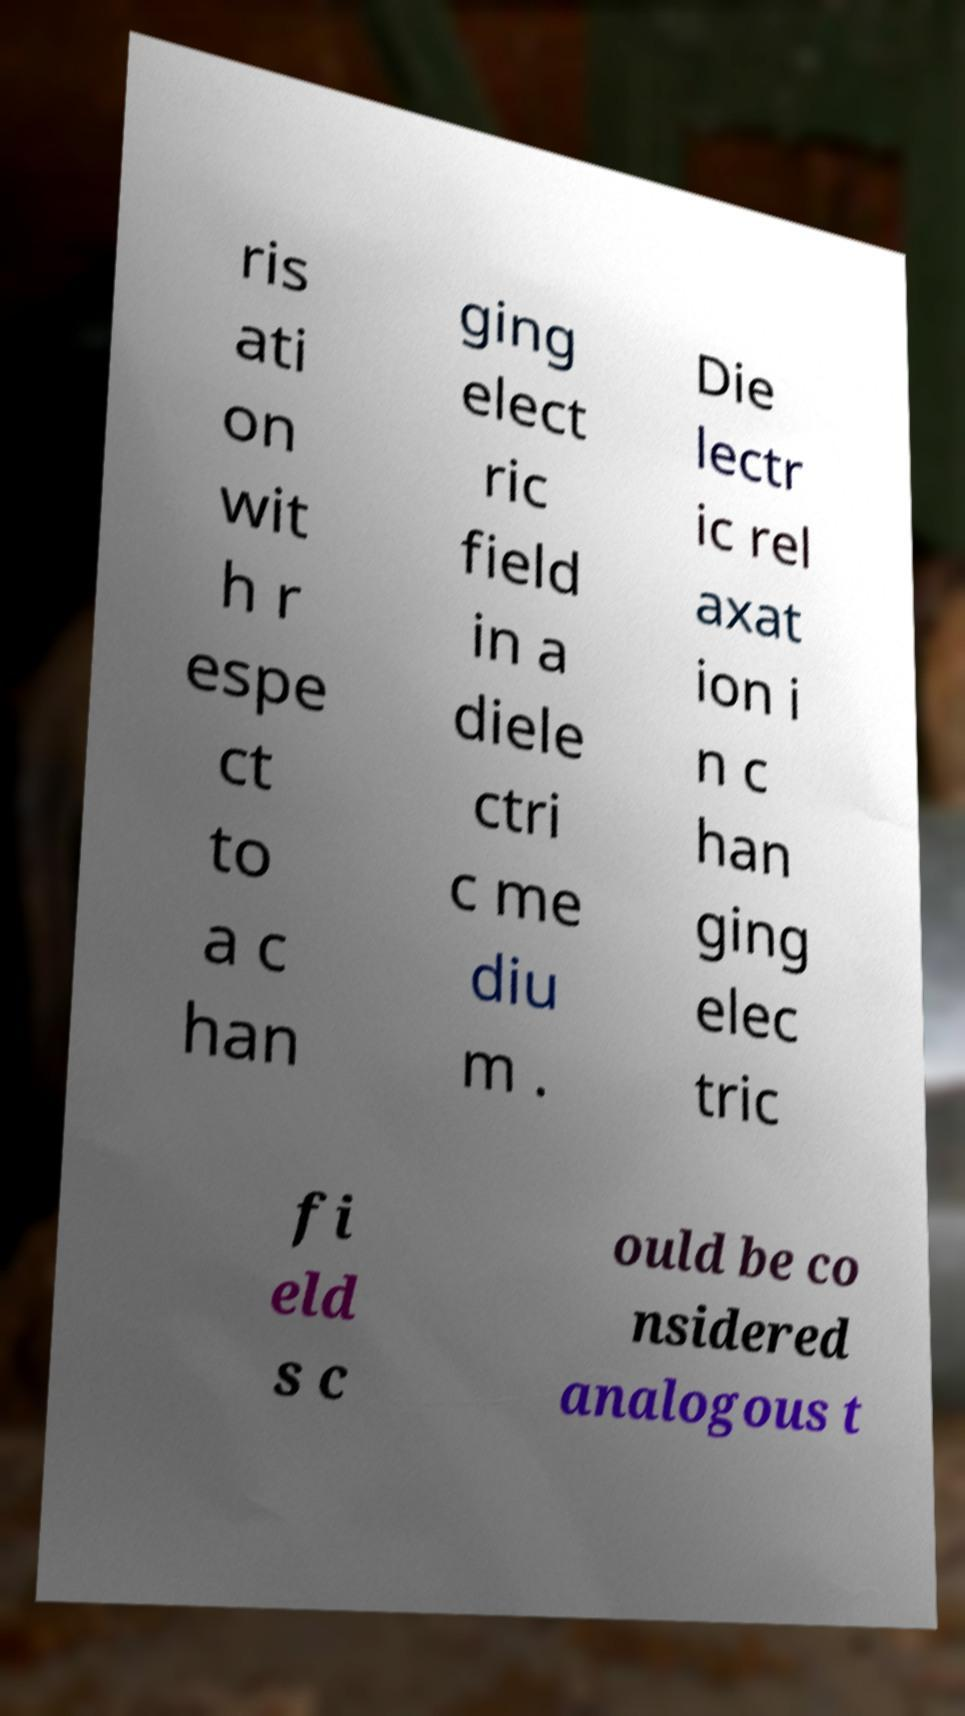Please read and relay the text visible in this image. What does it say? ris ati on wit h r espe ct to a c han ging elect ric field in a diele ctri c me diu m . Die lectr ic rel axat ion i n c han ging elec tric fi eld s c ould be co nsidered analogous t 